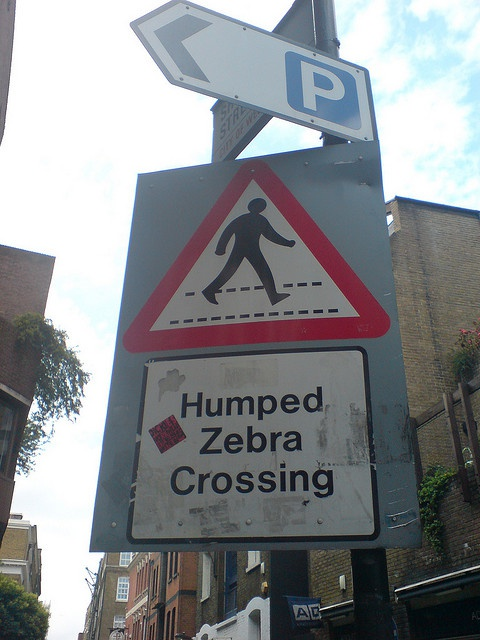Describe the objects in this image and their specific colors. I can see various objects in this image with different colors. 